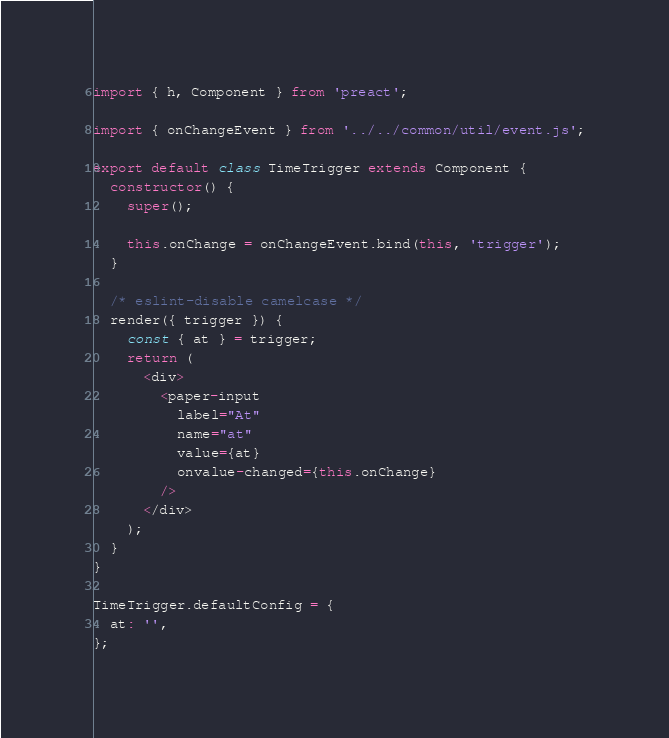Convert code to text. <code><loc_0><loc_0><loc_500><loc_500><_JavaScript_>import { h, Component } from 'preact';

import { onChangeEvent } from '../../common/util/event.js';

export default class TimeTrigger extends Component {
  constructor() {
    super();

    this.onChange = onChangeEvent.bind(this, 'trigger');
  }

  /* eslint-disable camelcase */
  render({ trigger }) {
    const { at } = trigger;
    return (
      <div>
        <paper-input
          label="At"
          name="at"
          value={at}
          onvalue-changed={this.onChange}
        />
      </div>
    );
  }
}

TimeTrigger.defaultConfig = {
  at: '',
};
</code> 